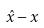Convert formula to latex. <formula><loc_0><loc_0><loc_500><loc_500>\hat { x } - x</formula> 